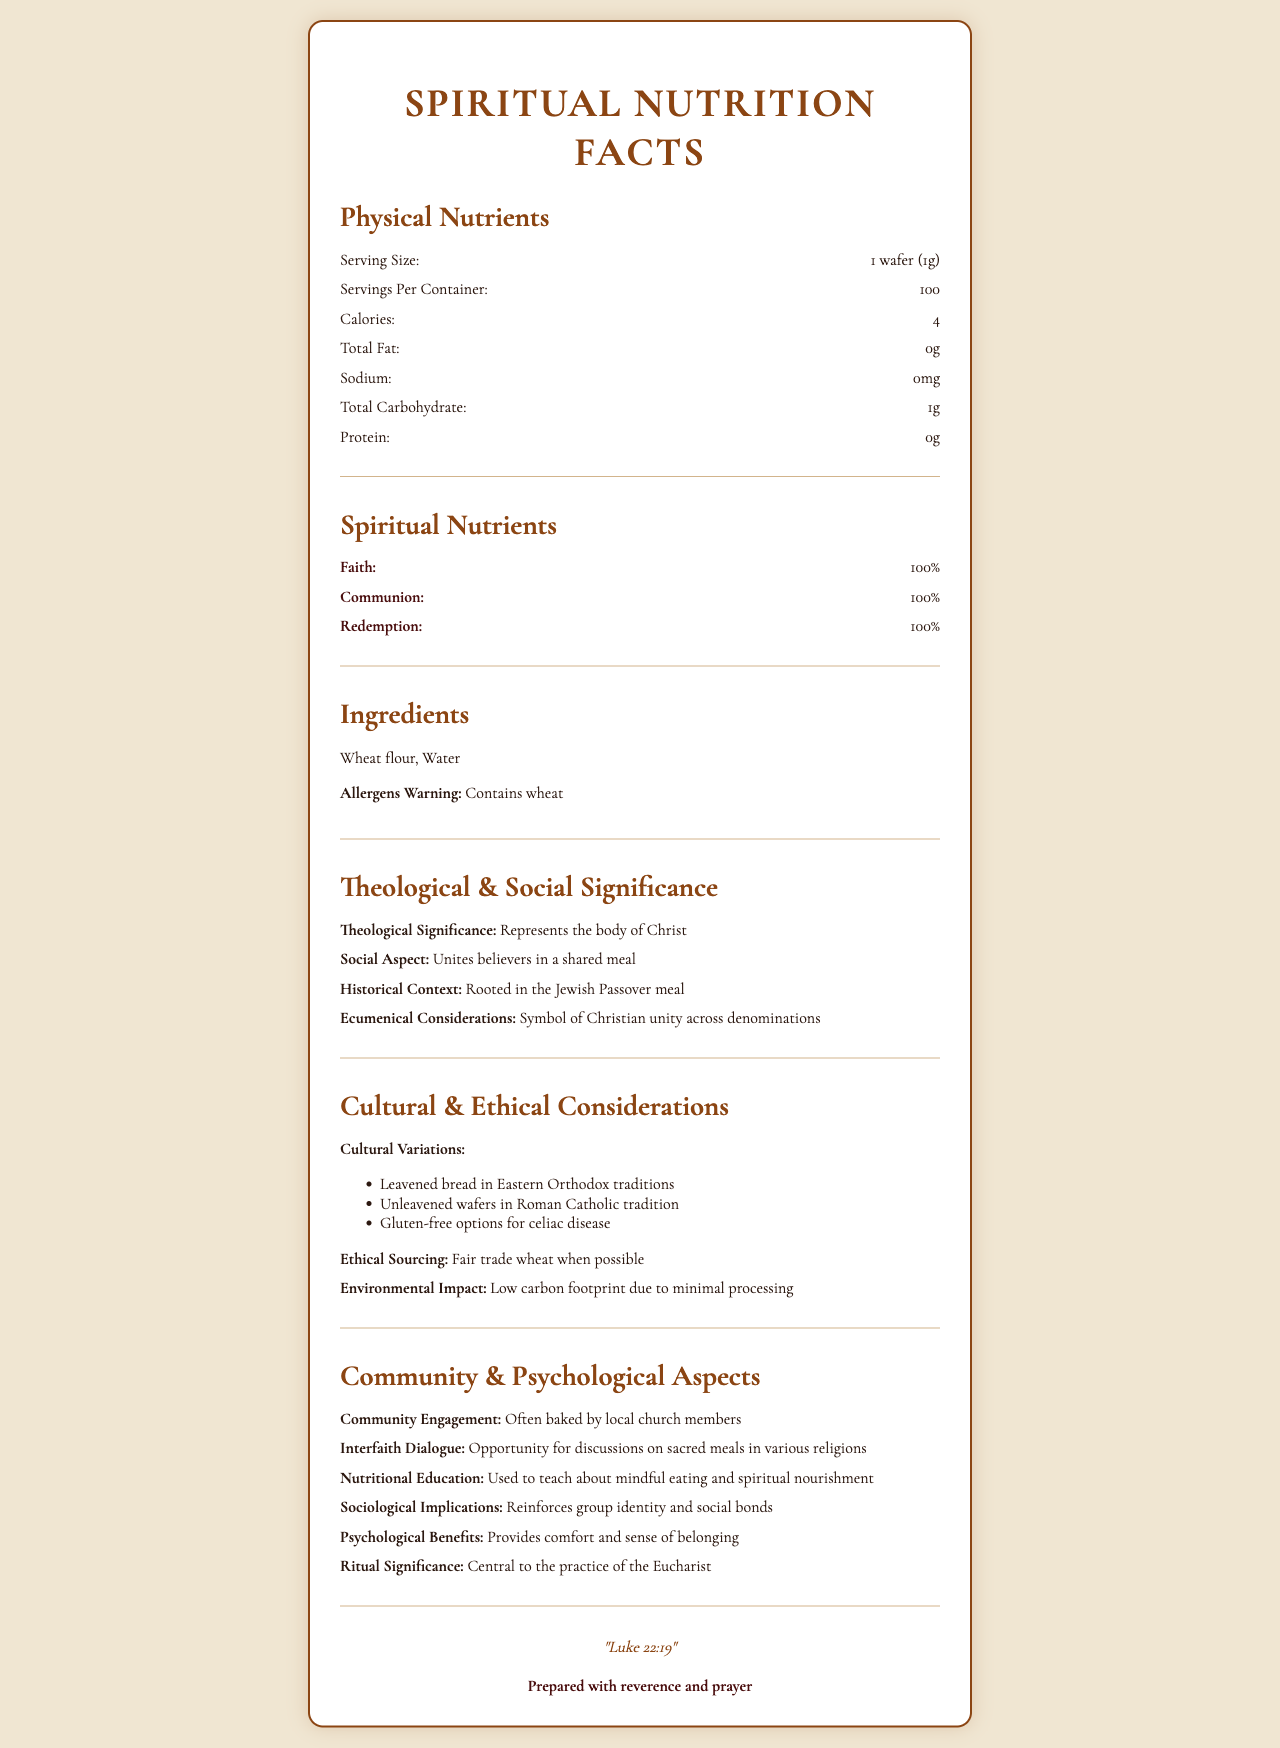what is the serving size of the communion bread? The serving size is mentioned under "Physical Nutrients" as "1 wafer (1g)".
Answer: 1 wafer (1g) how many calories does one serving of the communion bread contain? The calories per serving are stated as "4" in the Physical Nutrients section.
Answer: 4 what are the two main ingredients in the communion bread? The "Ingredients" section lists the ingredients as "Wheat flour" and "Water".
Answer: Wheat flour, Water what percentage of faith does the communion bread contain? The "Spiritual Nutrients" section shows "Faith: 100%".
Answer: 100% describe the theological significance of the communion bread. The "Theological Significance" is described as "Represents the body of Christ".
Answer: Represents the body of Christ what is the biblical reference mentioned for the communion bread? The "biblicalReference" at the end of the document is "Luke 22:19".
Answer: Luke 22:19 which of the following is included in the cultural variations of the communion bread?
A. Unleavened wafers
B. Leavened bread
C. Gluten-free options
D. All of the above The "Cultural Variations" section lists Unleavened wafers in Roman Catholic tradition, Leavened bread in Eastern Orthodox traditions, and Gluten-free options for celiac disease.
Answer: D which statement is true about the allergen warning?
1. Contains nuts
2. Contains dairy
3. Contains soy
4. Contains wheat The "Allergens Warning" section clearly states "Contains wheat."
Answer: 4 does the communion bread contain any protein? According to the "Physical Nutrients" section, the protein content is "0g."
Answer: No is the environmental impact of the communion bread high? The "Environmental Impact" is stated as "Low carbon footprint due to minimal processing."
Answer: No provide a summary of the entire document. The summary captures the essence of the document, discussing both the physical and spiritual facets of the communion bread, along with its cultural, social, and ethical aspects.
Answer: The document provides nutritional and spiritual information about communion bread, including physical nutrients, spiritual nutrients, ingredients, theological and social significance, cultural and ethical considerations, community and psychological aspects, and a biblical reference. The serving size is 1 wafer (1g) with 4 calories per serving. It contains wheat and water, with key spiritual nutrients being 100% faith, communion, and redemption. Various cultural variations, historical context, and considerations for sourcing and environmental impact are also discussed. how many servings are there per container? The "servingsPerContainer" is listed as "100" in the Physical Nutrients section.
Answer: 100 what is the total carbohydrate content in the communion bread? The "Total Carbohydrate" content is listed as "1g" in the Physical Nutrients section.
Answer: 1g what is the sociological implication of partaking in communion bread? The "Sociological Implications" section mentions "Reinforces group identity and social bonds."
Answer: Reinforces group identity and social bonds who prepares the communion bread, according to the document? The "Community Engagement" section states that the bread is often baked by "local church members."
Answer: Local church members does the document mention anything about the vitamin content of the communion bread? The document does not contain any information regarding the vitamin content of the communion bread.
Answer: Not enough information 